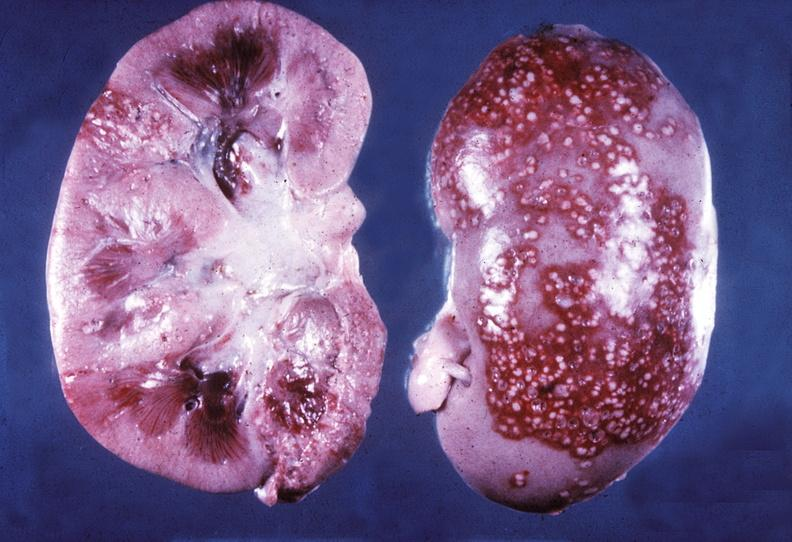what does this image show?
Answer the question using a single word or phrase. Kidney 